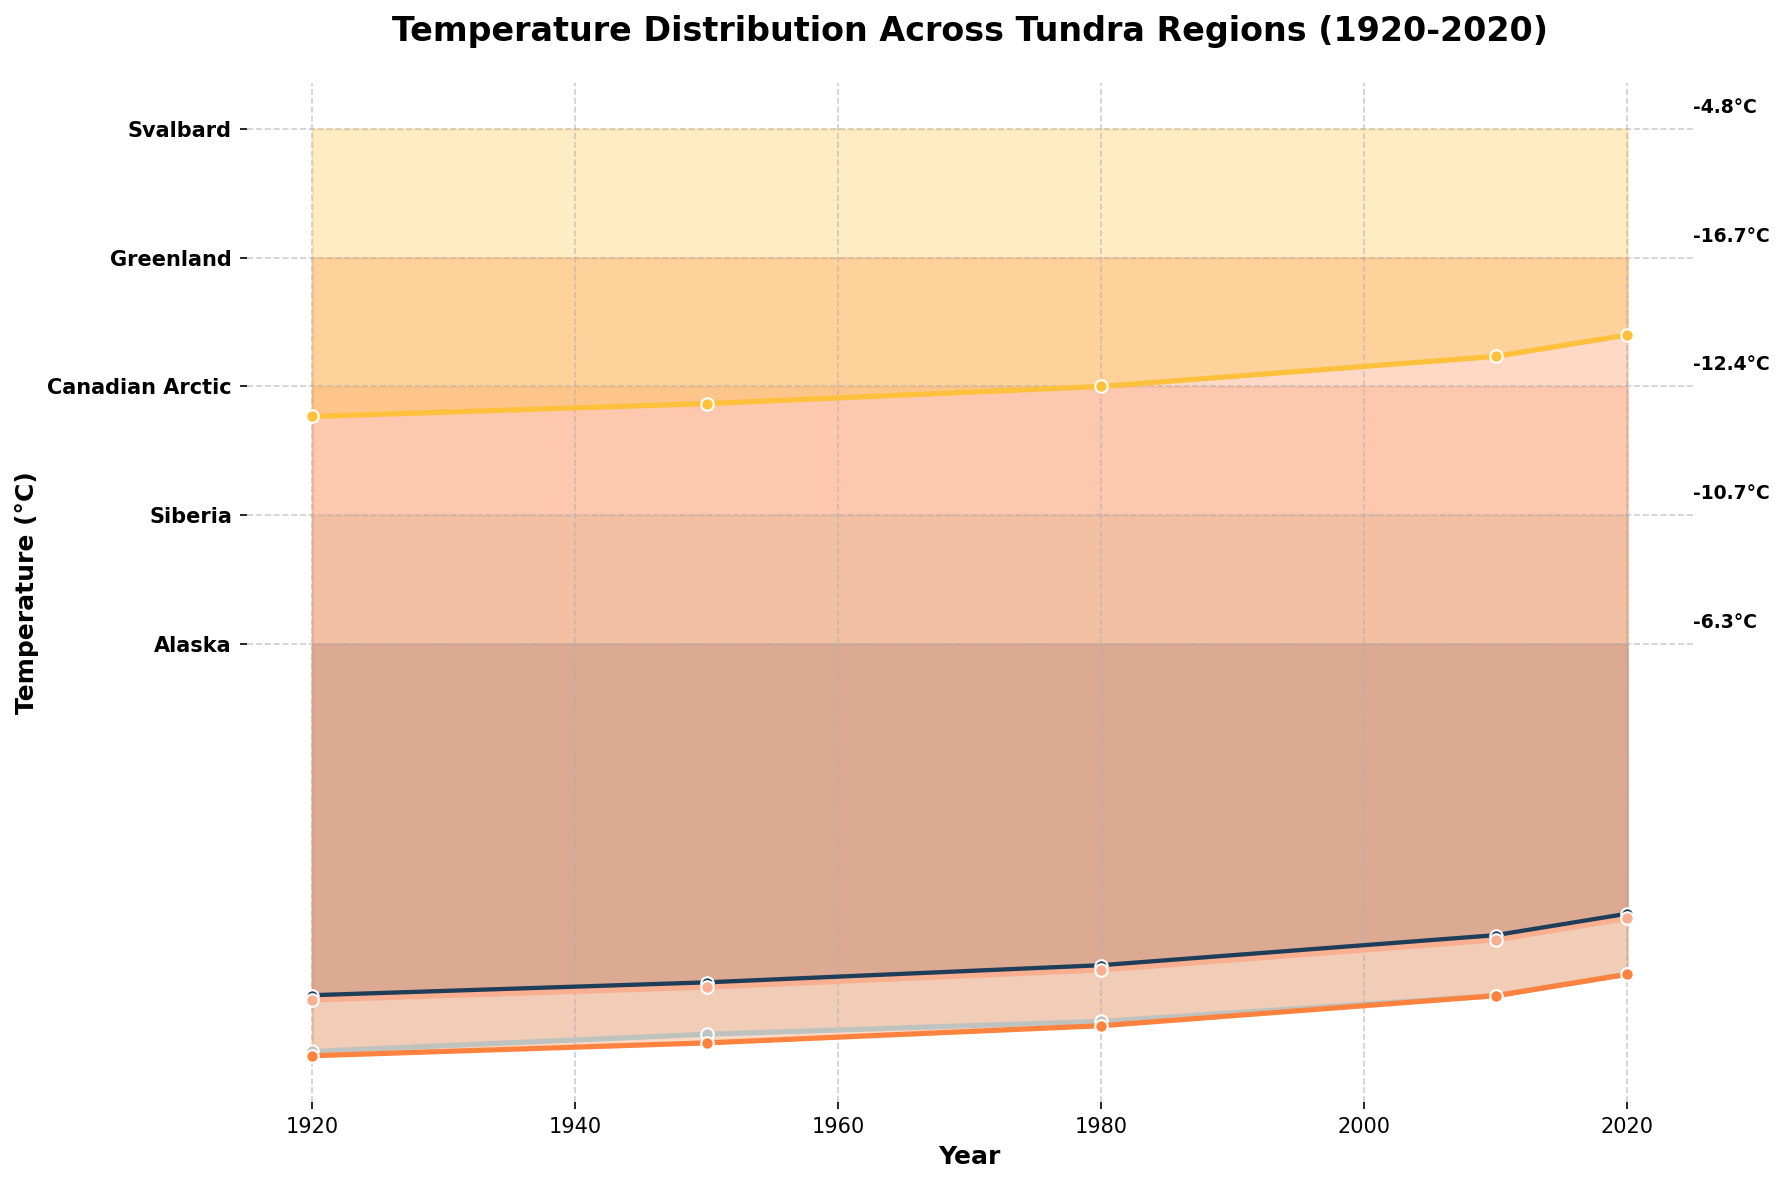What's the title of the figure? The title is displayed at the top of the plot, summarizing the main information being visualized.
Answer: Temperature Distribution Across Tundra Regions (1920-2020) What regions are represented in the plot? The y-axis labels indicate the regions being visualized in the plot.
Answer: Alaska, Siberia, Canadian Arctic, Greenland, Svalbard What is the temperature trend in Alaska from 1920 to 2020? Observing the plot for Alaska, the temperature values from 1920 to 2020 show a gradual increase (becoming less negative).
Answer: Increasing Which region has the coldest temperature in 1920? In the plot, the coldest temperature in 1920 corresponds to the region with the lowest temperature value on the temperature scale.
Answer: Greenland How does the temperature change in Greenland from 1920 to 2020 compare to the change in Svalbard? For a comparison, note the temperature values for both regions in 1920 and 2020. Greenland shows a change from -18.6°C to -16.7°C, while Svalbard changes from -6.7°C to -4.8°C. Comparing the differences: Greenland (-1.9°C) and Svalbard (-1.9°C).
Answer: Similar Which region shows the greatest temperature increase over the period? Calculate the difference between 1920 and 2020 temperatures for each region. The region with the largest positive change indicates the greatest increase.
Answer: Svalbard What is the approximate temperature in the Canadian Arctic in 1980? Find the Canadian Arctic data in 1980 on the plot, and read off the corresponding temperature value.
Answer: -13.6°C Which region had the least temperature variation over the past century? To find the region with the least variation, compare the temperature changes from 1920 to 2020 for each region. The smallest change indicates the least variation.
Answer: Canadian Arctic How many years are plotted for temperature data in each region? The plot displays markers for each year; counting these markers will show the number of years plotted per region.
Answer: Five Is there any region where temperatures decreased from 1920 to 2020? Check the temperature trend for each region. If the temperature values become more negative, it indicates a decrease.
Answer: No 